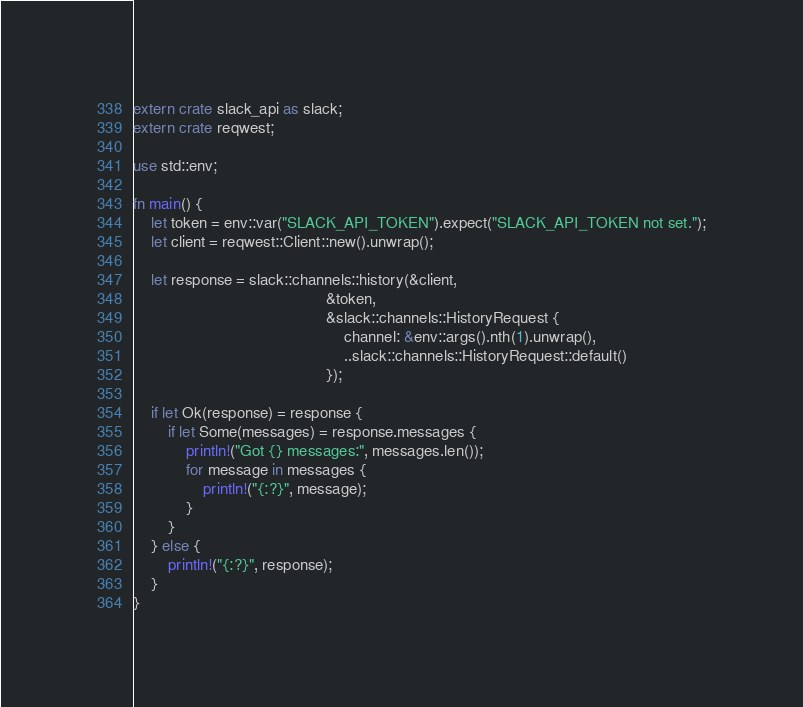Convert code to text. <code><loc_0><loc_0><loc_500><loc_500><_Rust_>extern crate slack_api as slack;
extern crate reqwest;

use std::env;

fn main() {
    let token = env::var("SLACK_API_TOKEN").expect("SLACK_API_TOKEN not set.");
    let client = reqwest::Client::new().unwrap();

    let response = slack::channels::history(&client,
                                            &token,
                                            &slack::channels::HistoryRequest {
                                                channel: &env::args().nth(1).unwrap(),
                                                ..slack::channels::HistoryRequest::default()
                                            });

    if let Ok(response) = response {
        if let Some(messages) = response.messages {
            println!("Got {} messages:", messages.len());
            for message in messages {
                println!("{:?}", message);
            }
        }
    } else {
        println!("{:?}", response);
    }
}
</code> 